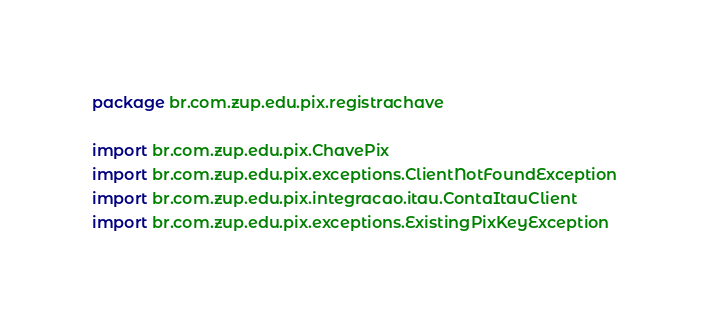Convert code to text. <code><loc_0><loc_0><loc_500><loc_500><_Kotlin_>package br.com.zup.edu.pix.registrachave

import br.com.zup.edu.pix.ChavePix
import br.com.zup.edu.pix.exceptions.ClientNotFoundException
import br.com.zup.edu.pix.integracao.itau.ContaItauClient
import br.com.zup.edu.pix.exceptions.ExistingPixKeyException</code> 